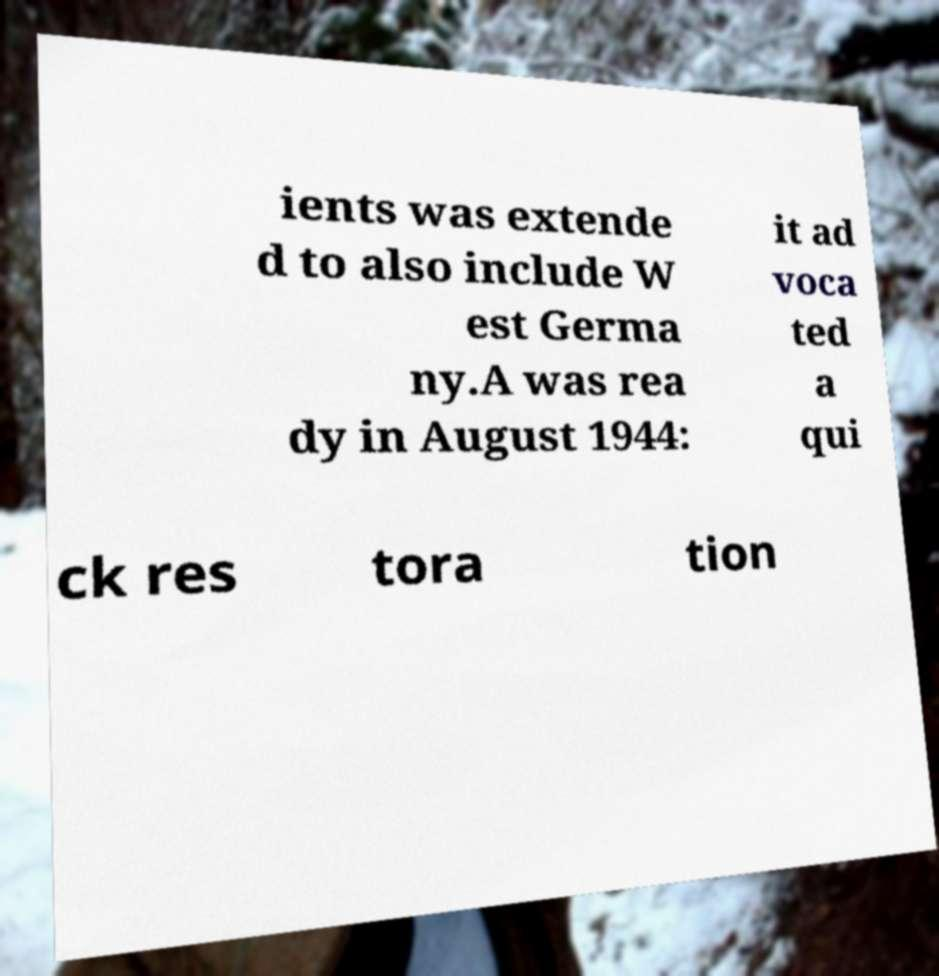Please read and relay the text visible in this image. What does it say? ients was extende d to also include W est Germa ny.A was rea dy in August 1944: it ad voca ted a qui ck res tora tion 